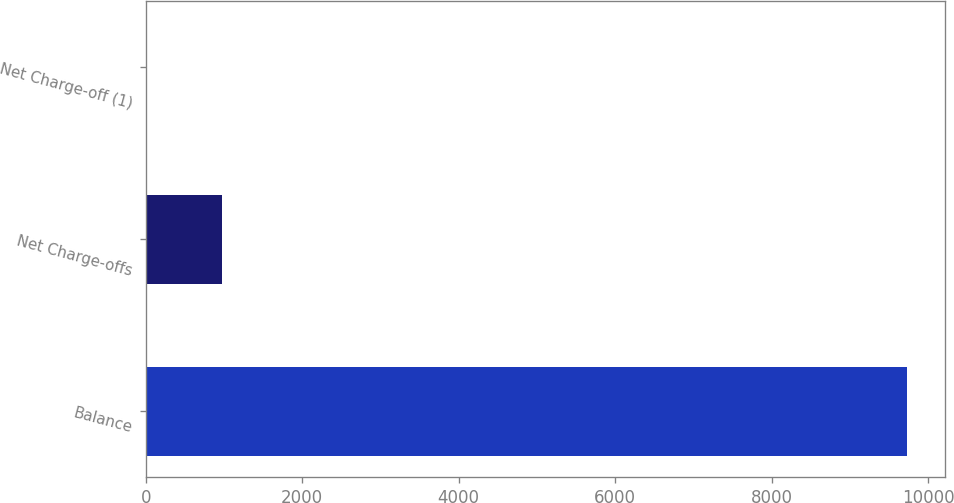<chart> <loc_0><loc_0><loc_500><loc_500><bar_chart><fcel>Balance<fcel>Net Charge-offs<fcel>Net Charge-off (1)<nl><fcel>9726<fcel>973.55<fcel>1.05<nl></chart> 